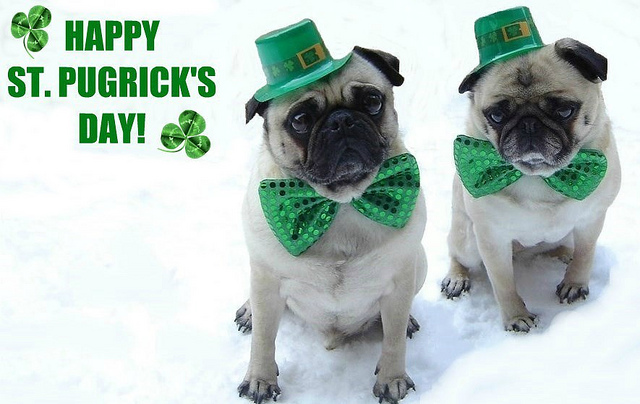What could a humorous caption for this image be? "When your human tells you to dress up for St. Patrick's Day and suddenly you're the center of every party!" What would the pugs' personalities be like if they could talk? The pug on the left would be the charismatic party planner, always ready with a witty joke and a mischievous glint in his eye. The pug on the right might be the more serious, thoughtful friend who loves to tell stories of old folklore and is always concerned with proper holiday attire. Together, they'd make a dynamic duo spreading joy and cheer. 